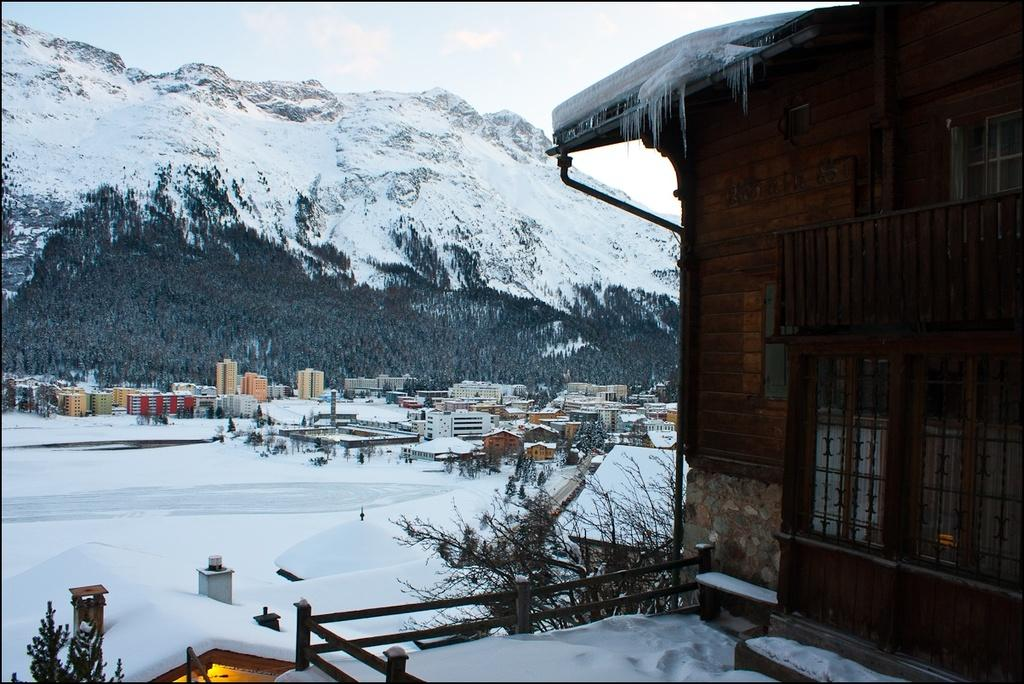What type of structures can be seen in the image? There are houses and buildings in the image. What other natural elements are present in the image? There are trees in the image. What is the weather condition in the image? There is snow visible in the image, indicating a snowy environment. Can you describe the landscape behind the buildings? There is a snowy hill behind the buildings. What is visible in the sky in the image? The sky is visible in the image. Where is the vase placed in the image? There is no vase present in the image. What type of writing can be seen on the houses in the image? There is no writing visible on the houses in the image. 